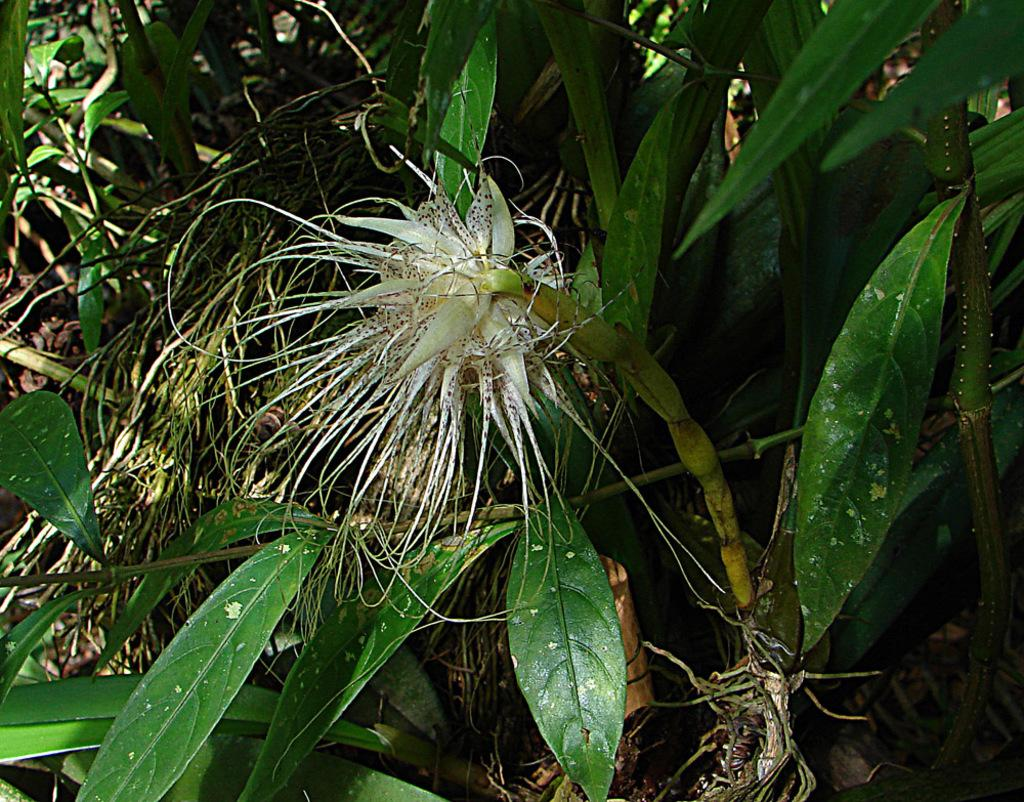What type of natural environment is visible in the image? There is grass in the image, which suggests a natural environment. Besides grass, what other elements can be seen in the image? There are plants and leaves visible in the image. How does the island appear in the image? There is no island present in the image; it features grass, plants, and leaves. Can you describe how the air is depicted in the image? The image does not depict the air or any specific conditions related to it. 